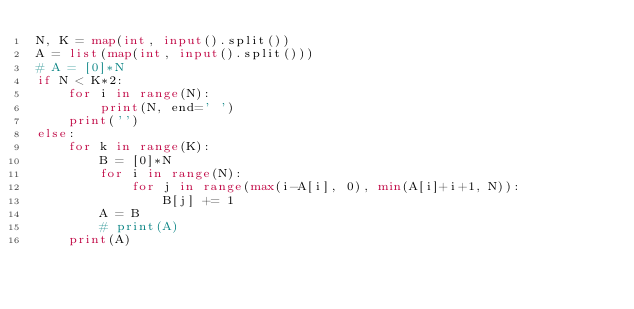Convert code to text. <code><loc_0><loc_0><loc_500><loc_500><_Python_>N, K = map(int, input().split())
A = list(map(int, input().split()))
# A = [0]*N
if N < K*2:
    for i in range(N):
        print(N, end=' ')
    print('')
else:
    for k in range(K):
        B = [0]*N
        for i in range(N):
            for j in range(max(i-A[i], 0), min(A[i]+i+1, N)):
                B[j] += 1
        A = B
        # print(A)
    print(A)</code> 